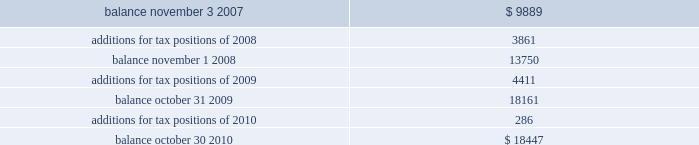Of global business , there are many transactions and calculations where the ultimate tax outcome is uncertain .
Some of these uncertainties arise as a consequence of cost reimbursement arrangements among related entities .
Although the company believes its estimates are reasonable , no assurance can be given that the final tax outcome of these matters will not be different than that which is reflected in the historical income tax provisions and accruals .
Such differences could have a material impact on the company 2019s income tax provision and operating results in the period in which such determination is made .
On november 4 , 2007 ( the first day of its 2008 fiscal year ) , the company adopted new accounting principles on accounting for uncertain tax positions .
These principles require companies to determine whether it is 201cmore likely than not 201d that a tax position will be sustained upon examination by the appropriate taxing authorities before any benefit can be recorded in the financial statements .
An uncertain income tax position will not be recognized if it has less than a 50% ( 50 % ) likelihood of being sustained .
There were no changes to the company 2019s liabilities for uncertain tax positions as a result of the adoption of these provisions .
As of october 30 , 2010 and october 31 , 2009 , the company had a liability of $ 18.4 million and $ 18.2 million , respectively , for gross unrealized tax benefits , all of which , if settled in the company 2019s favor , would lower the company 2019s effective tax rate in the period recorded .
In addition , as of october 30 , 2010 and october 31 , 2009 , the company had a liability of approximately $ 9.8 million and $ 8.0 million , respectively , for interest and penalties .
The total liability as of october 30 , 2010 and october 31 , 2009 of $ 28.3 million and $ 26.2 million , respectively , for uncertain tax positions is classified as non-current , and is included in other non-current liabilities , because the company believes that the ultimate payment or settlement of these liabilities will not occur within the next twelve months .
Prior to the adoption of these provisions , these amounts were included in current income tax payable .
The company includes interest and penalties related to unrecognized tax benefits within the provision for taxes in the condensed consolidated statements of income , and as a result , no change in classification was made upon adopting these provisions .
The condensed consolidated statements of income for fiscal years 2010 , 2009 and 2008 include $ 1.8 million , $ 1.7 million and $ 1.3 million , respectively , of interest and penalties related to these uncertain tax positions .
Due to the complexity associated with its tax uncertainties , the company cannot make a reasonably reliable estimate as to the period in which it expects to settle the liabilities associated with these uncertain tax positions .
The table summarizes the changes in the total amounts of uncertain tax positions for fiscal 2008 through fiscal 2010. .
Fiscal years 2004 and 2005 irs examination during the fourth quarter of fiscal 2007 , the irs completed its field examination of the company 2019s fiscal years 2004 and 2005 .
On january 2 , 2008 , the irs issued its report for fiscal 2004 and 2005 , which included proposed adjustments related to these two fiscal years .
The company has recorded taxes and penalties related to certain of these proposed adjustments .
There are four items with an additional potential total tax liability of $ 46 million .
The company has concluded , based on discussions with its tax advisors , that these four items are not likely to result in any additional tax liability .
Therefore , the company has not recorded any additional tax liability for these items and is appealing these proposed adjustments through the normal processes for the resolution of differences between the irs and taxpayers .
The company 2019s initial meetings with the appellate division of the irs were held during fiscal analog devices , inc .
Notes to consolidated financial statements 2014 ( continued ) .
By what amount does the interest and penalties expense exceed the payment for interest and penalties in 2010? 
Computations: (9.8 - 8.0)
Answer: 1.8. 